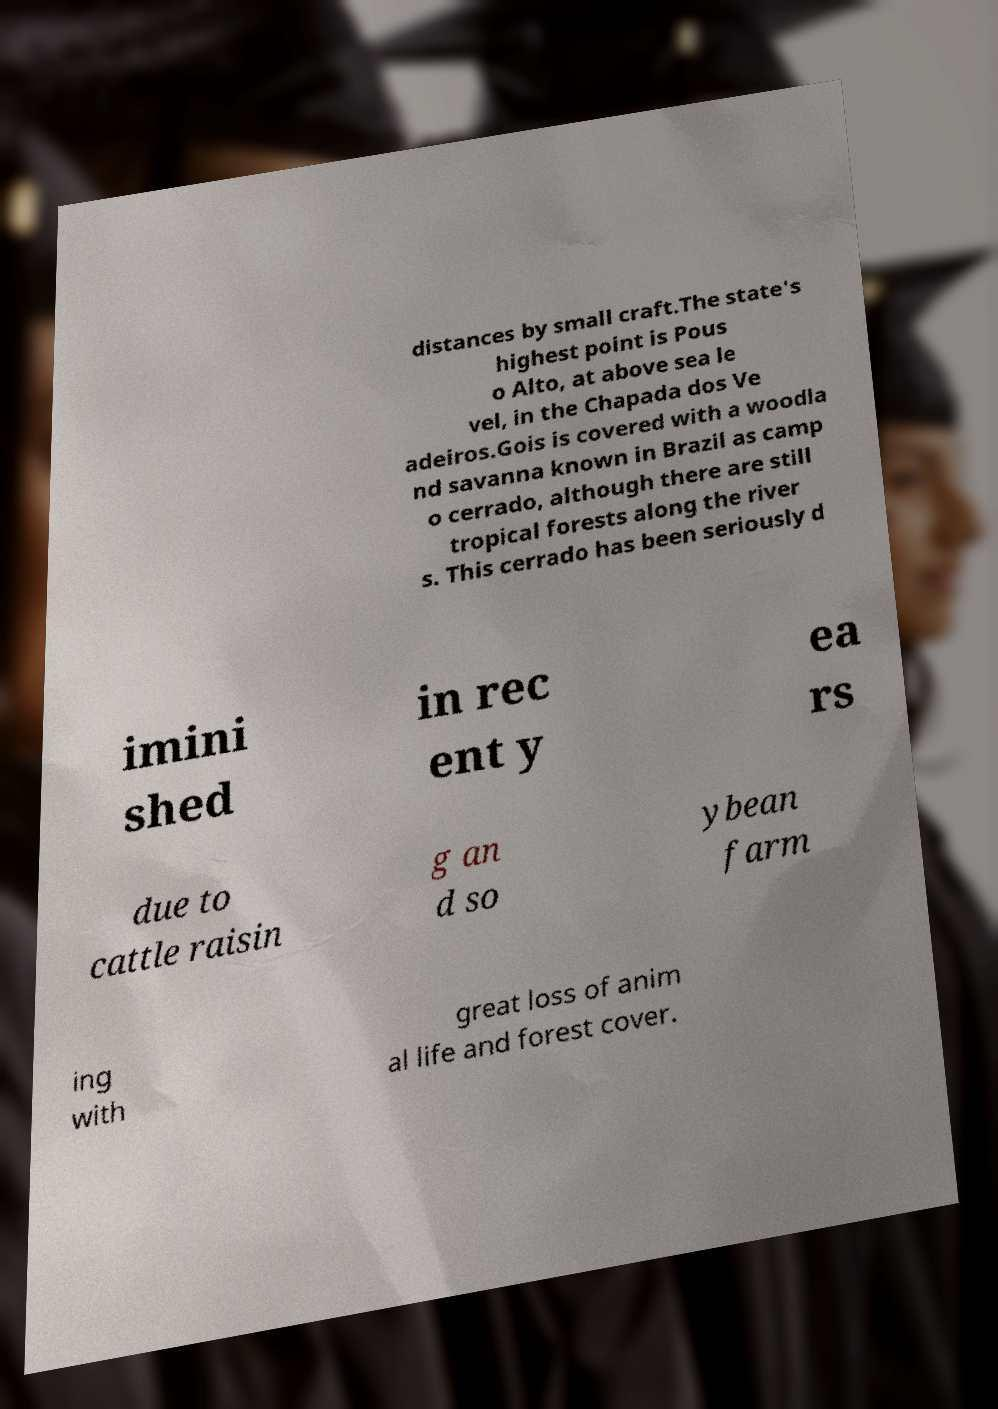There's text embedded in this image that I need extracted. Can you transcribe it verbatim? distances by small craft.The state's highest point is Pous o Alto, at above sea le vel, in the Chapada dos Ve adeiros.Gois is covered with a woodla nd savanna known in Brazil as camp o cerrado, although there are still tropical forests along the river s. This cerrado has been seriously d imini shed in rec ent y ea rs due to cattle raisin g an d so ybean farm ing with great loss of anim al life and forest cover. 